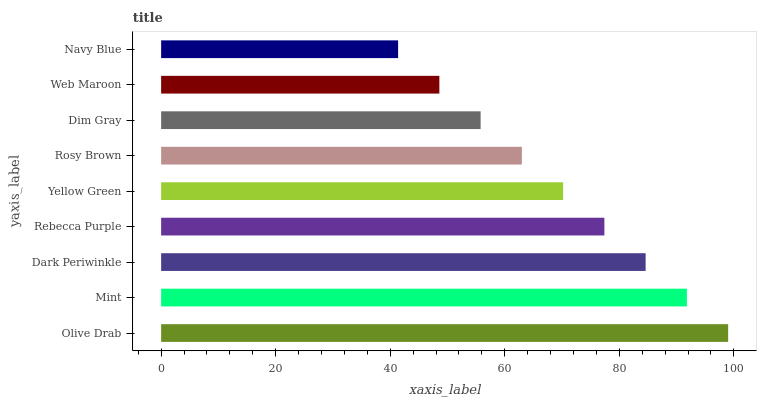Is Navy Blue the minimum?
Answer yes or no. Yes. Is Olive Drab the maximum?
Answer yes or no. Yes. Is Mint the minimum?
Answer yes or no. No. Is Mint the maximum?
Answer yes or no. No. Is Olive Drab greater than Mint?
Answer yes or no. Yes. Is Mint less than Olive Drab?
Answer yes or no. Yes. Is Mint greater than Olive Drab?
Answer yes or no. No. Is Olive Drab less than Mint?
Answer yes or no. No. Is Yellow Green the high median?
Answer yes or no. Yes. Is Yellow Green the low median?
Answer yes or no. Yes. Is Dim Gray the high median?
Answer yes or no. No. Is Rosy Brown the low median?
Answer yes or no. No. 